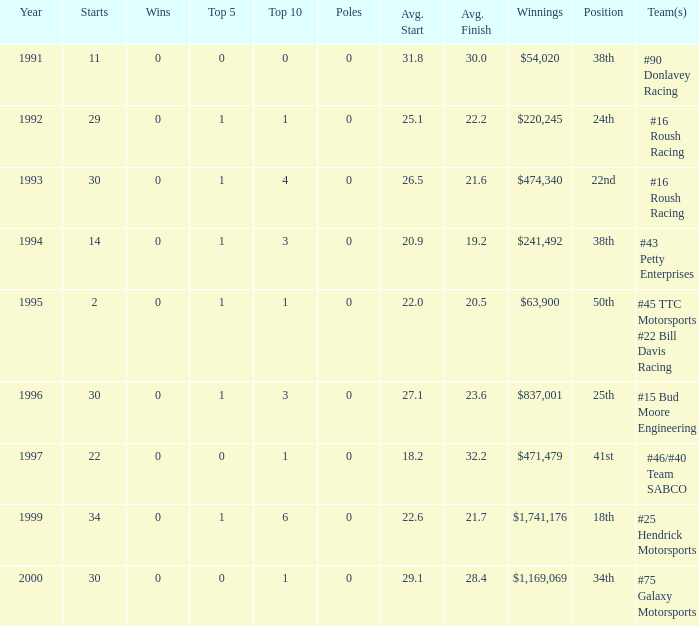What the rank in the top 10 when the  winnings were $1,741,176? 6.0. 